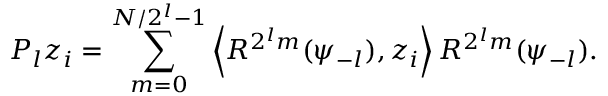Convert formula to latex. <formula><loc_0><loc_0><loc_500><loc_500>P _ { l } z _ { i } = \sum _ { m = 0 } ^ { N / 2 ^ { l } - 1 } \left \langle R ^ { 2 ^ { l } m } ( \psi _ { - l } ) , z _ { i } \right \rangle R ^ { 2 ^ { l } m } ( \psi _ { - l } ) .</formula> 